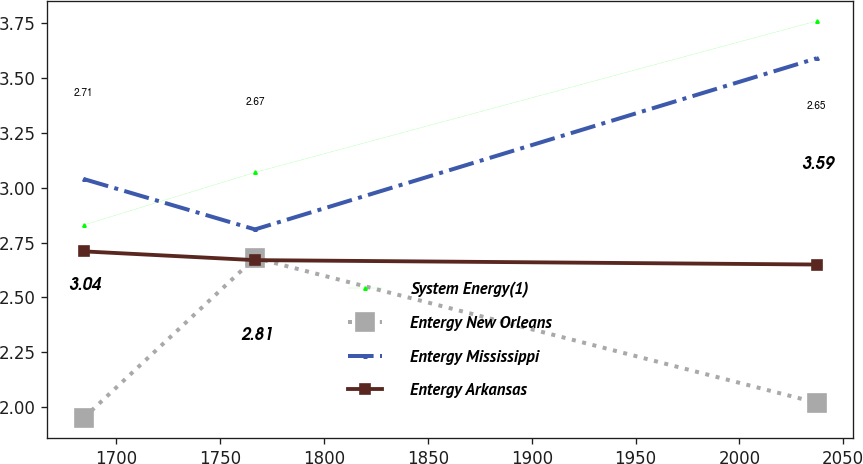<chart> <loc_0><loc_0><loc_500><loc_500><line_chart><ecel><fcel>System Energy(1)<fcel>Entergy New Orleans<fcel>Entergy Mississippi<fcel>Entergy Arkansas<nl><fcel>1684.19<fcel>2.83<fcel>1.95<fcel>3.04<fcel>2.71<nl><fcel>1766.75<fcel>3.07<fcel>2.68<fcel>2.81<fcel>2.67<nl><fcel>2037.17<fcel>3.76<fcel>2.02<fcel>3.59<fcel>2.65<nl></chart> 